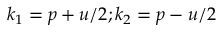<formula> <loc_0><loc_0><loc_500><loc_500>k _ { 1 } = p + u / 2 ; k _ { 2 } = p - u / 2</formula> 